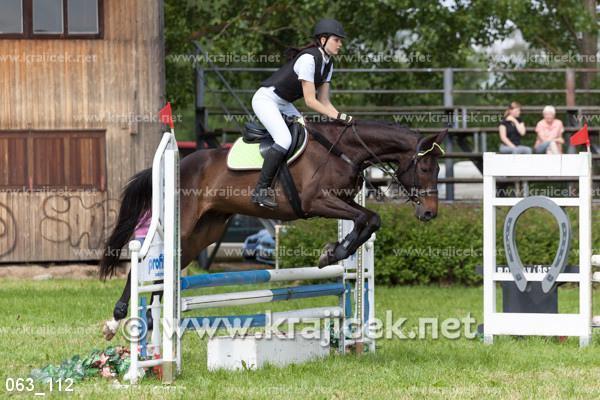What kind of horseback riding style is this?
Pick the correct solution from the four options below to address the question.
Options: Western, arabian, english, group. English. 